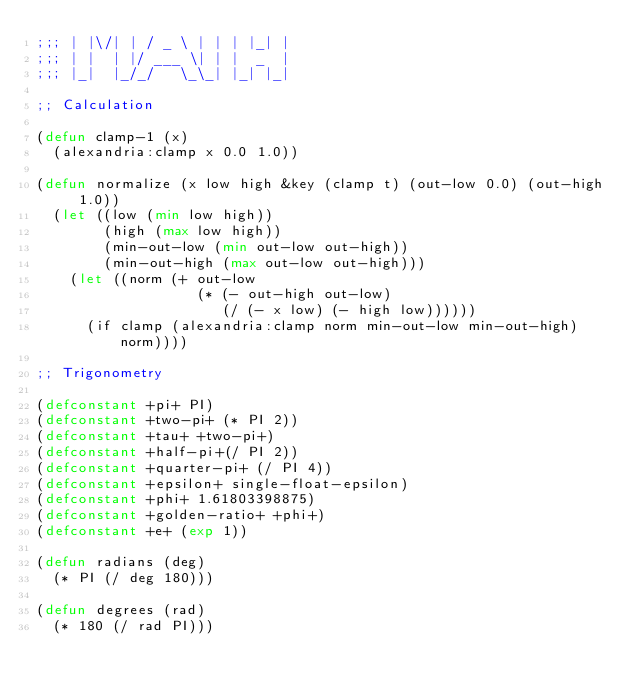Convert code to text. <code><loc_0><loc_0><loc_500><loc_500><_Lisp_>;;; | |\/| | / _ \ | | | |_| |
;;; | |  | |/ ___ \| | |  _  |
;;; |_|  |_/_/   \_\_| |_| |_|

;; Calculation

(defun clamp-1 (x)
  (alexandria:clamp x 0.0 1.0))

(defun normalize (x low high &key (clamp t) (out-low 0.0) (out-high 1.0))
  (let ((low (min low high))
        (high (max low high))
        (min-out-low (min out-low out-high))
        (min-out-high (max out-low out-high)))
    (let ((norm (+ out-low
                   (* (- out-high out-low)
                      (/ (- x low) (- high low))))))
      (if clamp (alexandria:clamp norm min-out-low min-out-high) norm))))

;; Trigonometry

(defconstant +pi+ PI)
(defconstant +two-pi+ (* PI 2))
(defconstant +tau+ +two-pi+)
(defconstant +half-pi+(/ PI 2))
(defconstant +quarter-pi+ (/ PI 4))
(defconstant +epsilon+ single-float-epsilon)
(defconstant +phi+ 1.61803398875)
(defconstant +golden-ratio+ +phi+)
(defconstant +e+ (exp 1))

(defun radians (deg)
  (* PI (/ deg 180)))

(defun degrees (rad)
  (* 180 (/ rad PI)))
</code> 